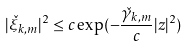<formula> <loc_0><loc_0><loc_500><loc_500>| \check { \xi } _ { k , m } | ^ { 2 } \leq c \exp ( - \frac { \check { \gamma } _ { k , m } } { c } | z | ^ { 2 } )</formula> 